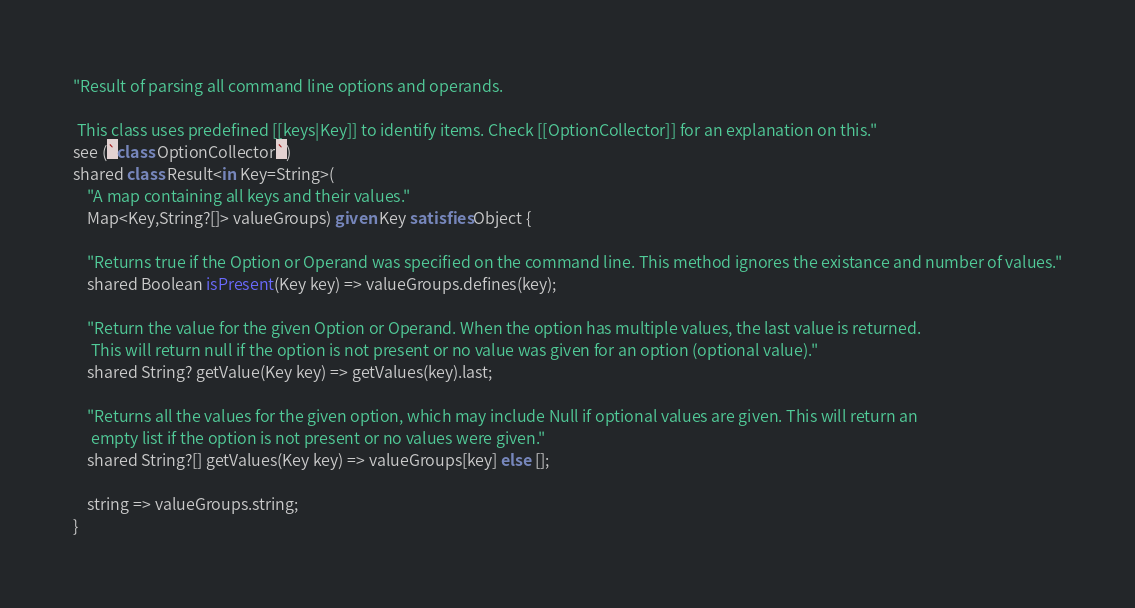<code> <loc_0><loc_0><loc_500><loc_500><_Ceylon_>"Result of parsing all command line options and operands.

 This class uses predefined [[keys|Key]] to identify items. Check [[OptionCollector]] for an explanation on this."
see (`class OptionCollector`)
shared class Result<in Key=String>(
	"A map containing all keys and their values."
	Map<Key,String?[]> valueGroups) given Key satisfies Object {

	"Returns true if the Option or Operand was specified on the command line. This method ignores the existance and number of values."
	shared Boolean isPresent(Key key) => valueGroups.defines(key);

	"Return the value for the given Option or Operand. When the option has multiple values, the last value is returned.
	 This will return null if the option is not present or no value was given for an option (optional value)."
	shared String? getValue(Key key) => getValues(key).last;

	"Returns all the values for the given option, which may include Null if optional values are given. This will return an
	 empty list if the option is not present or no values were given."
	shared String?[] getValues(Key key) => valueGroups[key] else [];

	string => valueGroups.string;
}
</code> 